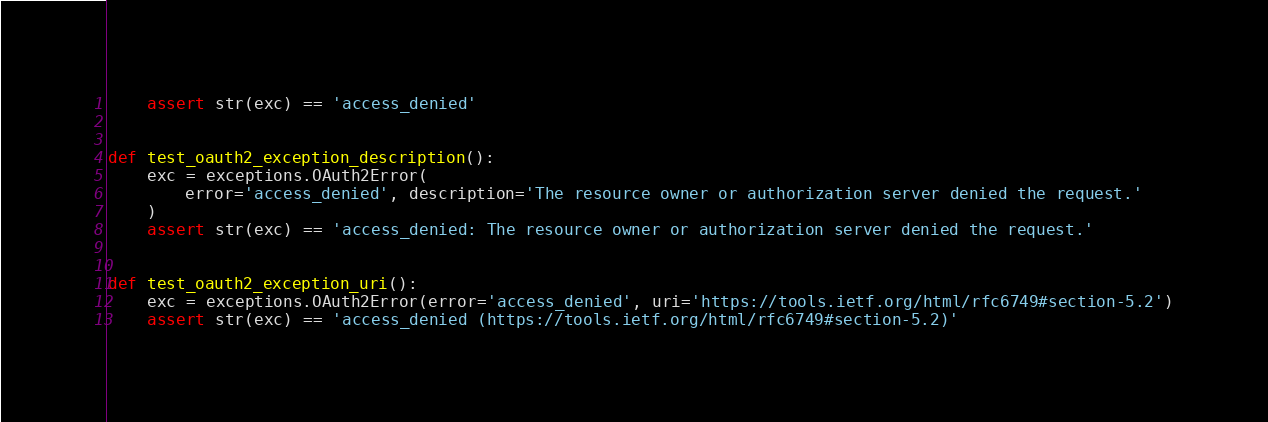<code> <loc_0><loc_0><loc_500><loc_500><_Python_>    assert str(exc) == 'access_denied'


def test_oauth2_exception_description():
    exc = exceptions.OAuth2Error(
        error='access_denied', description='The resource owner or authorization server denied the request.'
    )
    assert str(exc) == 'access_denied: The resource owner or authorization server denied the request.'


def test_oauth2_exception_uri():
    exc = exceptions.OAuth2Error(error='access_denied', uri='https://tools.ietf.org/html/rfc6749#section-5.2')
    assert str(exc) == 'access_denied (https://tools.ietf.org/html/rfc6749#section-5.2)'
</code> 